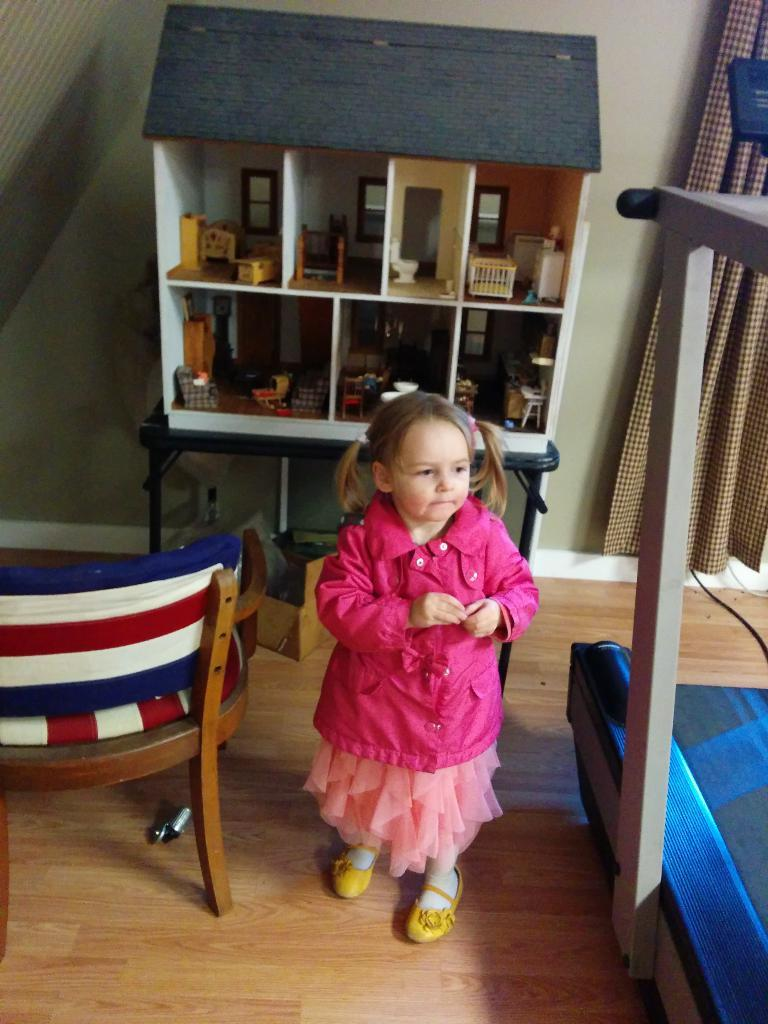Who is present in the image? There is a girl in the image. Where is the girl located? The girl is in a living room. What furniture can be seen in the living room? There is a chair and a bed in the living room. What type of window treatment is present in the living room? There is a curtain in the living room. What architectural feature is present in the living room? There is a wall in the living room. What type of dwelling is shown in the image? There is a ready-made house in the image. What is the weather like in the living room? The weather is not applicable to the living room, as it is an indoor setting. How many centimeters are there between the girl's veins in the image? There is no information about the girl's veins in the image, and therefore we cannot determine the distance between them. 